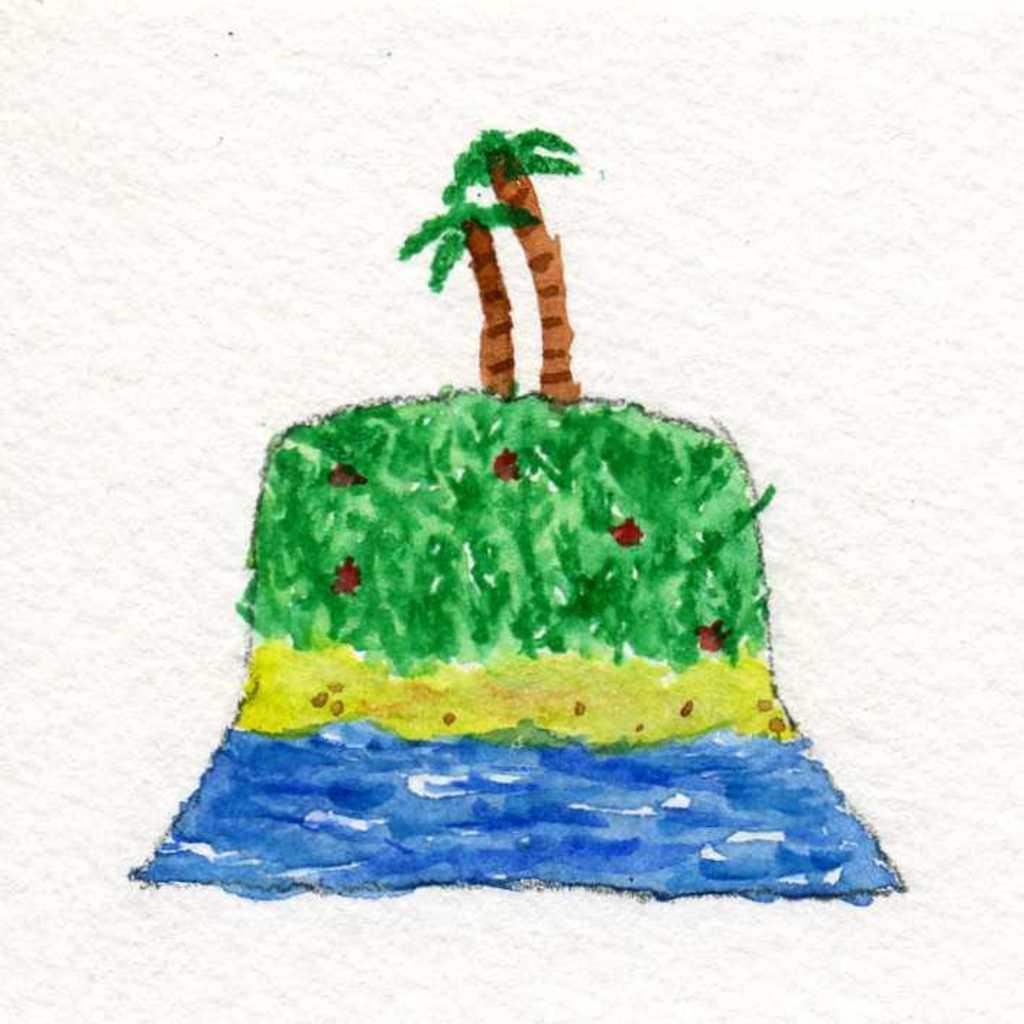Describe this image in one or two sentences. In the image there are paintings of trees, water and grass. 